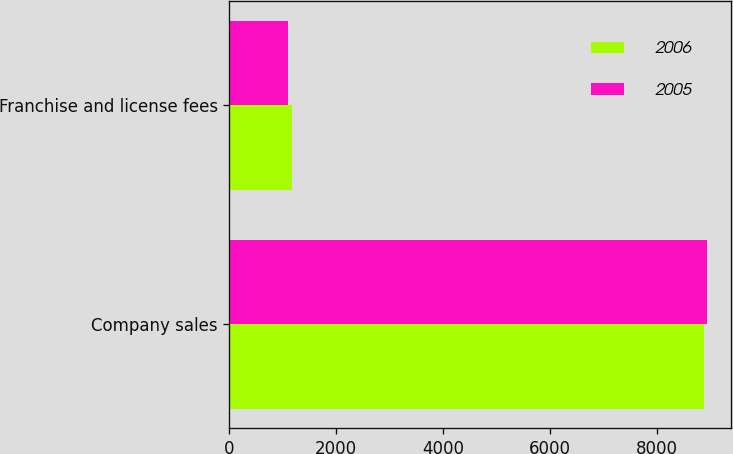Convert chart to OTSL. <chart><loc_0><loc_0><loc_500><loc_500><stacked_bar_chart><ecel><fcel>Company sales<fcel>Franchise and license fees<nl><fcel>2006<fcel>8886<fcel>1176<nl><fcel>2005<fcel>8944<fcel>1095<nl></chart> 